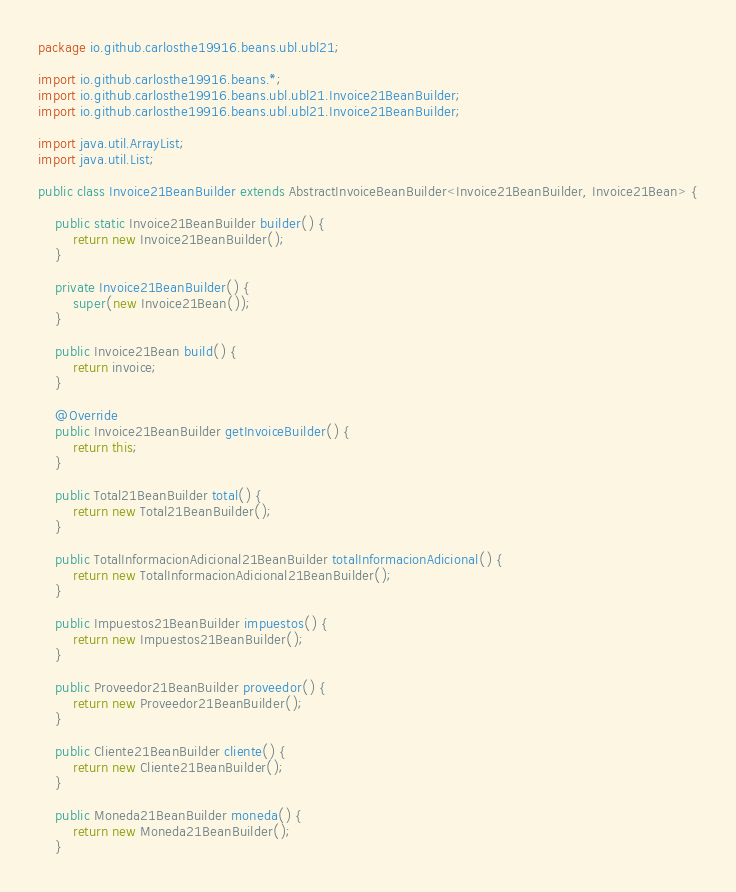<code> <loc_0><loc_0><loc_500><loc_500><_Java_>package io.github.carlosthe19916.beans.ubl.ubl21;

import io.github.carlosthe19916.beans.*;
import io.github.carlosthe19916.beans.ubl.ubl21.Invoice21BeanBuilder;
import io.github.carlosthe19916.beans.ubl.ubl21.Invoice21BeanBuilder;

import java.util.ArrayList;
import java.util.List;

public class Invoice21BeanBuilder extends AbstractInvoiceBeanBuilder<Invoice21BeanBuilder, Invoice21Bean> {

    public static Invoice21BeanBuilder builder() {
        return new Invoice21BeanBuilder();
    }

    private Invoice21BeanBuilder() {
        super(new Invoice21Bean());
    }

    public Invoice21Bean build() {
        return invoice;
    }

    @Override
    public Invoice21BeanBuilder getInvoiceBuilder() {
        return this;
    }

    public Total21BeanBuilder total() {
        return new Total21BeanBuilder();
    }

    public TotalInformacionAdicional21BeanBuilder totalInformacionAdicional() {
        return new TotalInformacionAdicional21BeanBuilder();
    }

    public Impuestos21BeanBuilder impuestos() {
        return new Impuestos21BeanBuilder();
    }

    public Proveedor21BeanBuilder proveedor() {
        return new Proveedor21BeanBuilder();
    }

    public Cliente21BeanBuilder cliente() {
        return new Cliente21BeanBuilder();
    }

    public Moneda21BeanBuilder moneda() {
        return new Moneda21BeanBuilder();
    }
</code> 